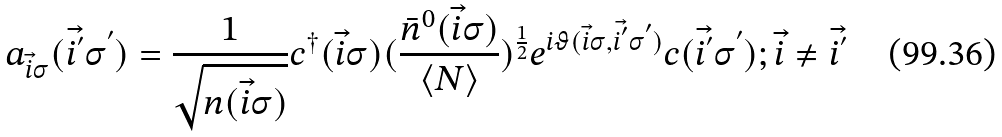<formula> <loc_0><loc_0><loc_500><loc_500>a _ { { \vec { i } } \sigma } ( { \vec { i ^ { ^ { \prime } } } } \sigma ^ { ^ { \prime } } ) = \frac { 1 } { \sqrt { n ( { \vec { i } } \sigma ) } } c ^ { \dagger } ( { \vec { i } } \sigma ) ( \frac { { \bar { n } } ^ { 0 } ( { \vec { i } } \sigma ) } { \langle N \rangle } ) ^ { \frac { 1 } { 2 } } e ^ { i \vartheta ( { \vec { i } } \sigma , { \vec { i ^ { ^ { \prime } } } } \sigma ^ { ^ { \prime } } ) } c ( { \vec { i ^ { ^ { \prime } } } } \sigma ^ { ^ { \prime } } ) ; { \vec { i } } \neq { \vec { i ^ { ^ { \prime } } } }</formula> 